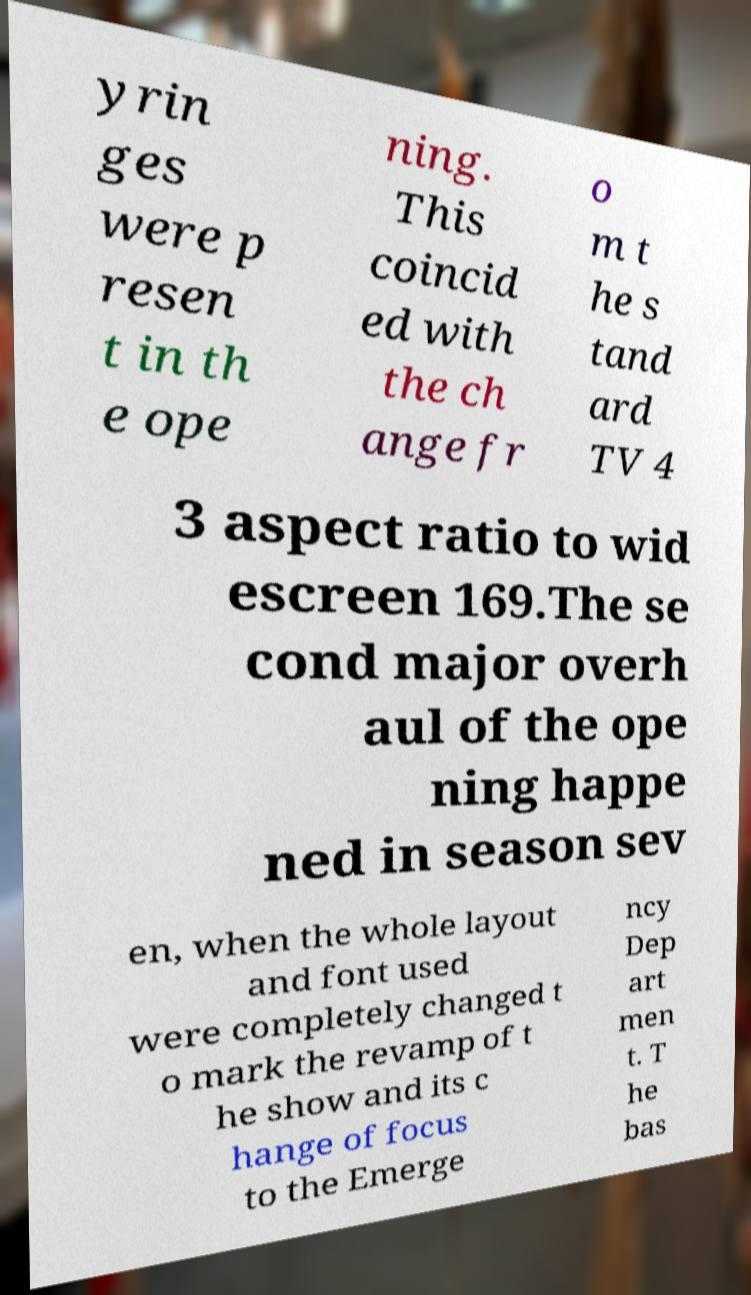Can you accurately transcribe the text from the provided image for me? yrin ges were p resen t in th e ope ning. This coincid ed with the ch ange fr o m t he s tand ard TV 4 3 aspect ratio to wid escreen 169.The se cond major overh aul of the ope ning happe ned in season sev en, when the whole layout and font used were completely changed t o mark the revamp of t he show and its c hange of focus to the Emerge ncy Dep art men t. T he bas 